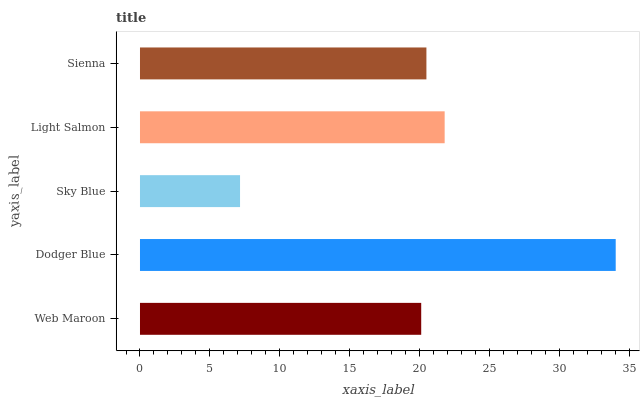Is Sky Blue the minimum?
Answer yes or no. Yes. Is Dodger Blue the maximum?
Answer yes or no. Yes. Is Dodger Blue the minimum?
Answer yes or no. No. Is Sky Blue the maximum?
Answer yes or no. No. Is Dodger Blue greater than Sky Blue?
Answer yes or no. Yes. Is Sky Blue less than Dodger Blue?
Answer yes or no. Yes. Is Sky Blue greater than Dodger Blue?
Answer yes or no. No. Is Dodger Blue less than Sky Blue?
Answer yes or no. No. Is Sienna the high median?
Answer yes or no. Yes. Is Sienna the low median?
Answer yes or no. Yes. Is Web Maroon the high median?
Answer yes or no. No. Is Web Maroon the low median?
Answer yes or no. No. 